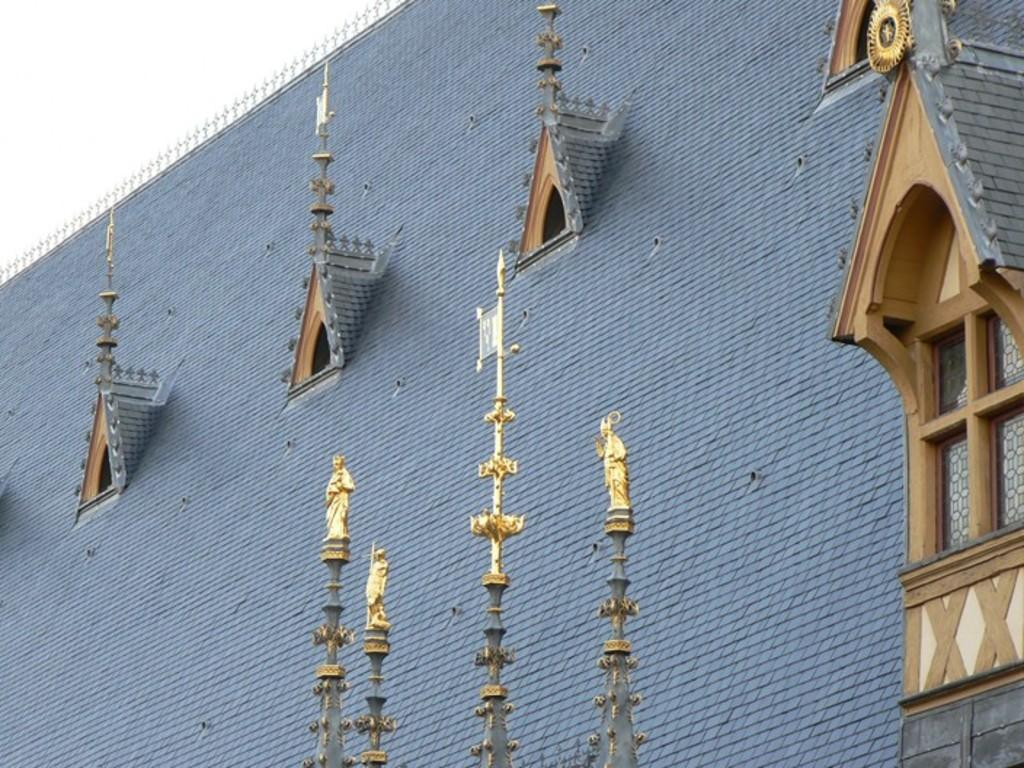What is the main structure visible in the image? There is a wall of a building in the image. What features can be seen on the wall? There are ventilators and glass windows on the wall. Are there any decorative elements on the building? Yes, there are small sculptures on the building. What can be seen in the top left corner of the image? The sky is visible in the top left corner of the image. How many dolls are sitting on the windowsill in the image? There are no dolls present in the image. What team is responsible for maintaining the ventilators on the building? The image does not provide information about the team responsible for maintaining the ventilators. 